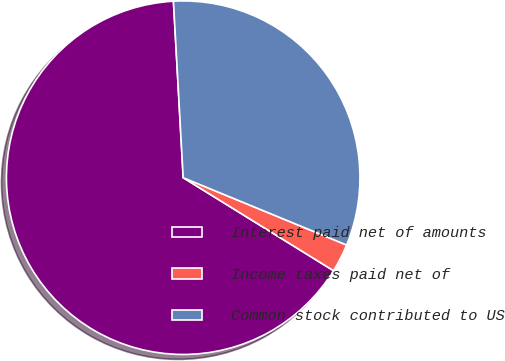Convert chart to OTSL. <chart><loc_0><loc_0><loc_500><loc_500><pie_chart><fcel>Interest paid net of amounts<fcel>Income taxes paid net of<fcel>Common stock contributed to US<nl><fcel>65.31%<fcel>2.6%<fcel>32.1%<nl></chart> 